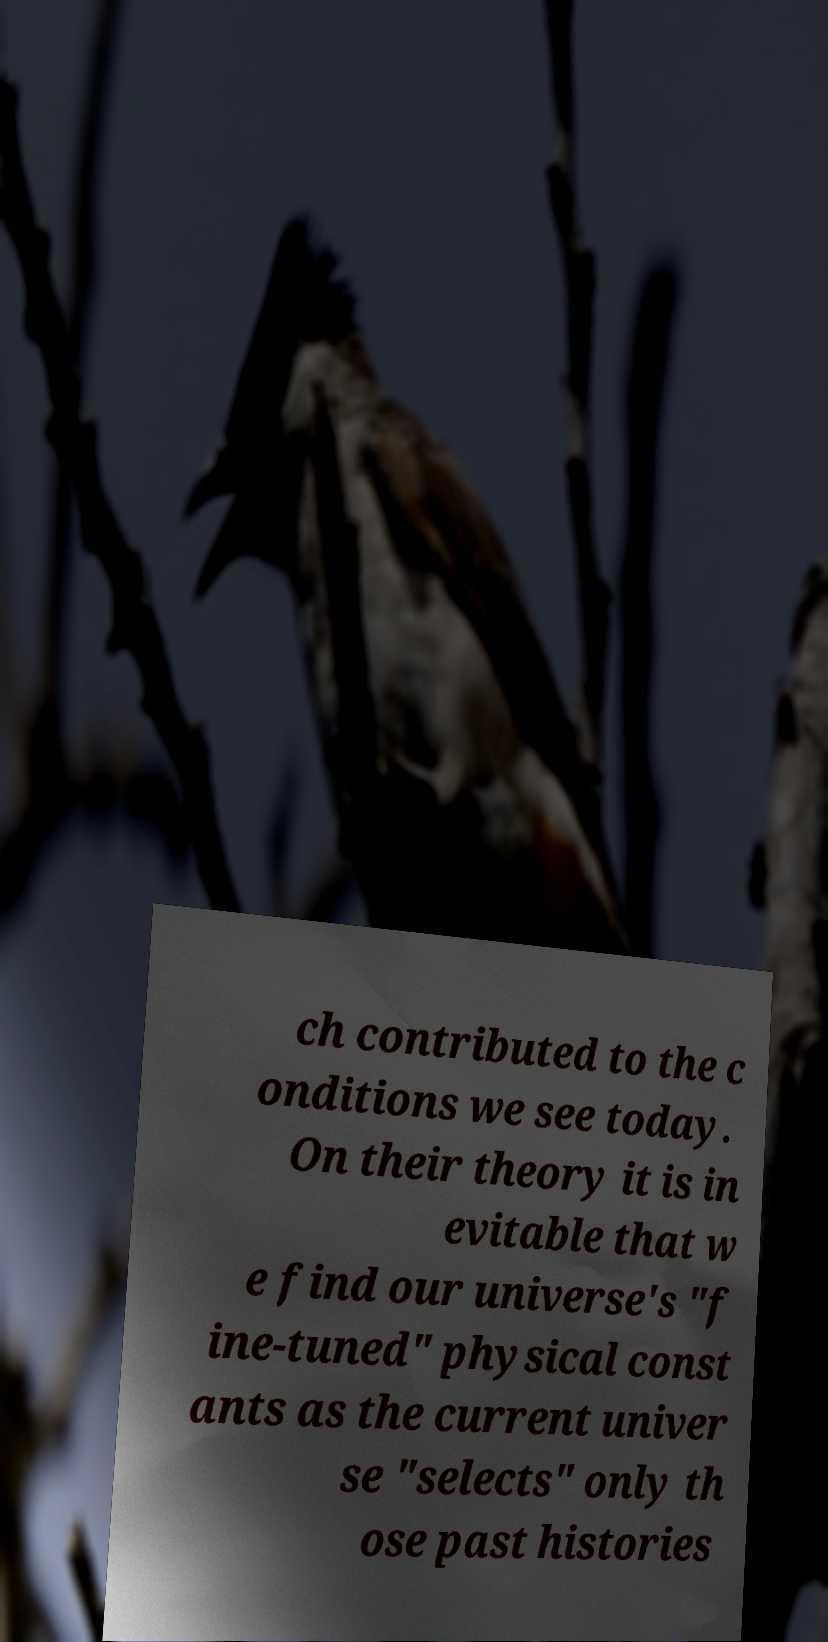Please read and relay the text visible in this image. What does it say? ch contributed to the c onditions we see today. On their theory it is in evitable that w e find our universe's "f ine-tuned" physical const ants as the current univer se "selects" only th ose past histories 